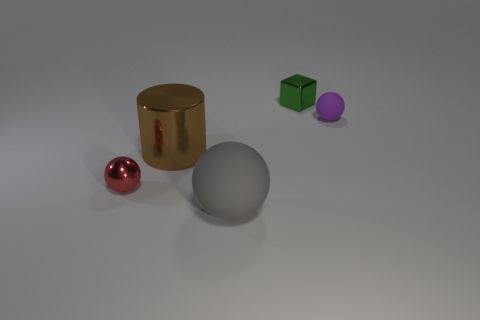Subtract all green balls. Subtract all green blocks. How many balls are left? 3 Add 5 big green cylinders. How many objects exist? 10 Subtract all blocks. How many objects are left? 4 Add 5 purple matte objects. How many purple matte objects are left? 6 Add 1 small blue spheres. How many small blue spheres exist? 1 Subtract 0 green cylinders. How many objects are left? 5 Subtract all large spheres. Subtract all shiny things. How many objects are left? 1 